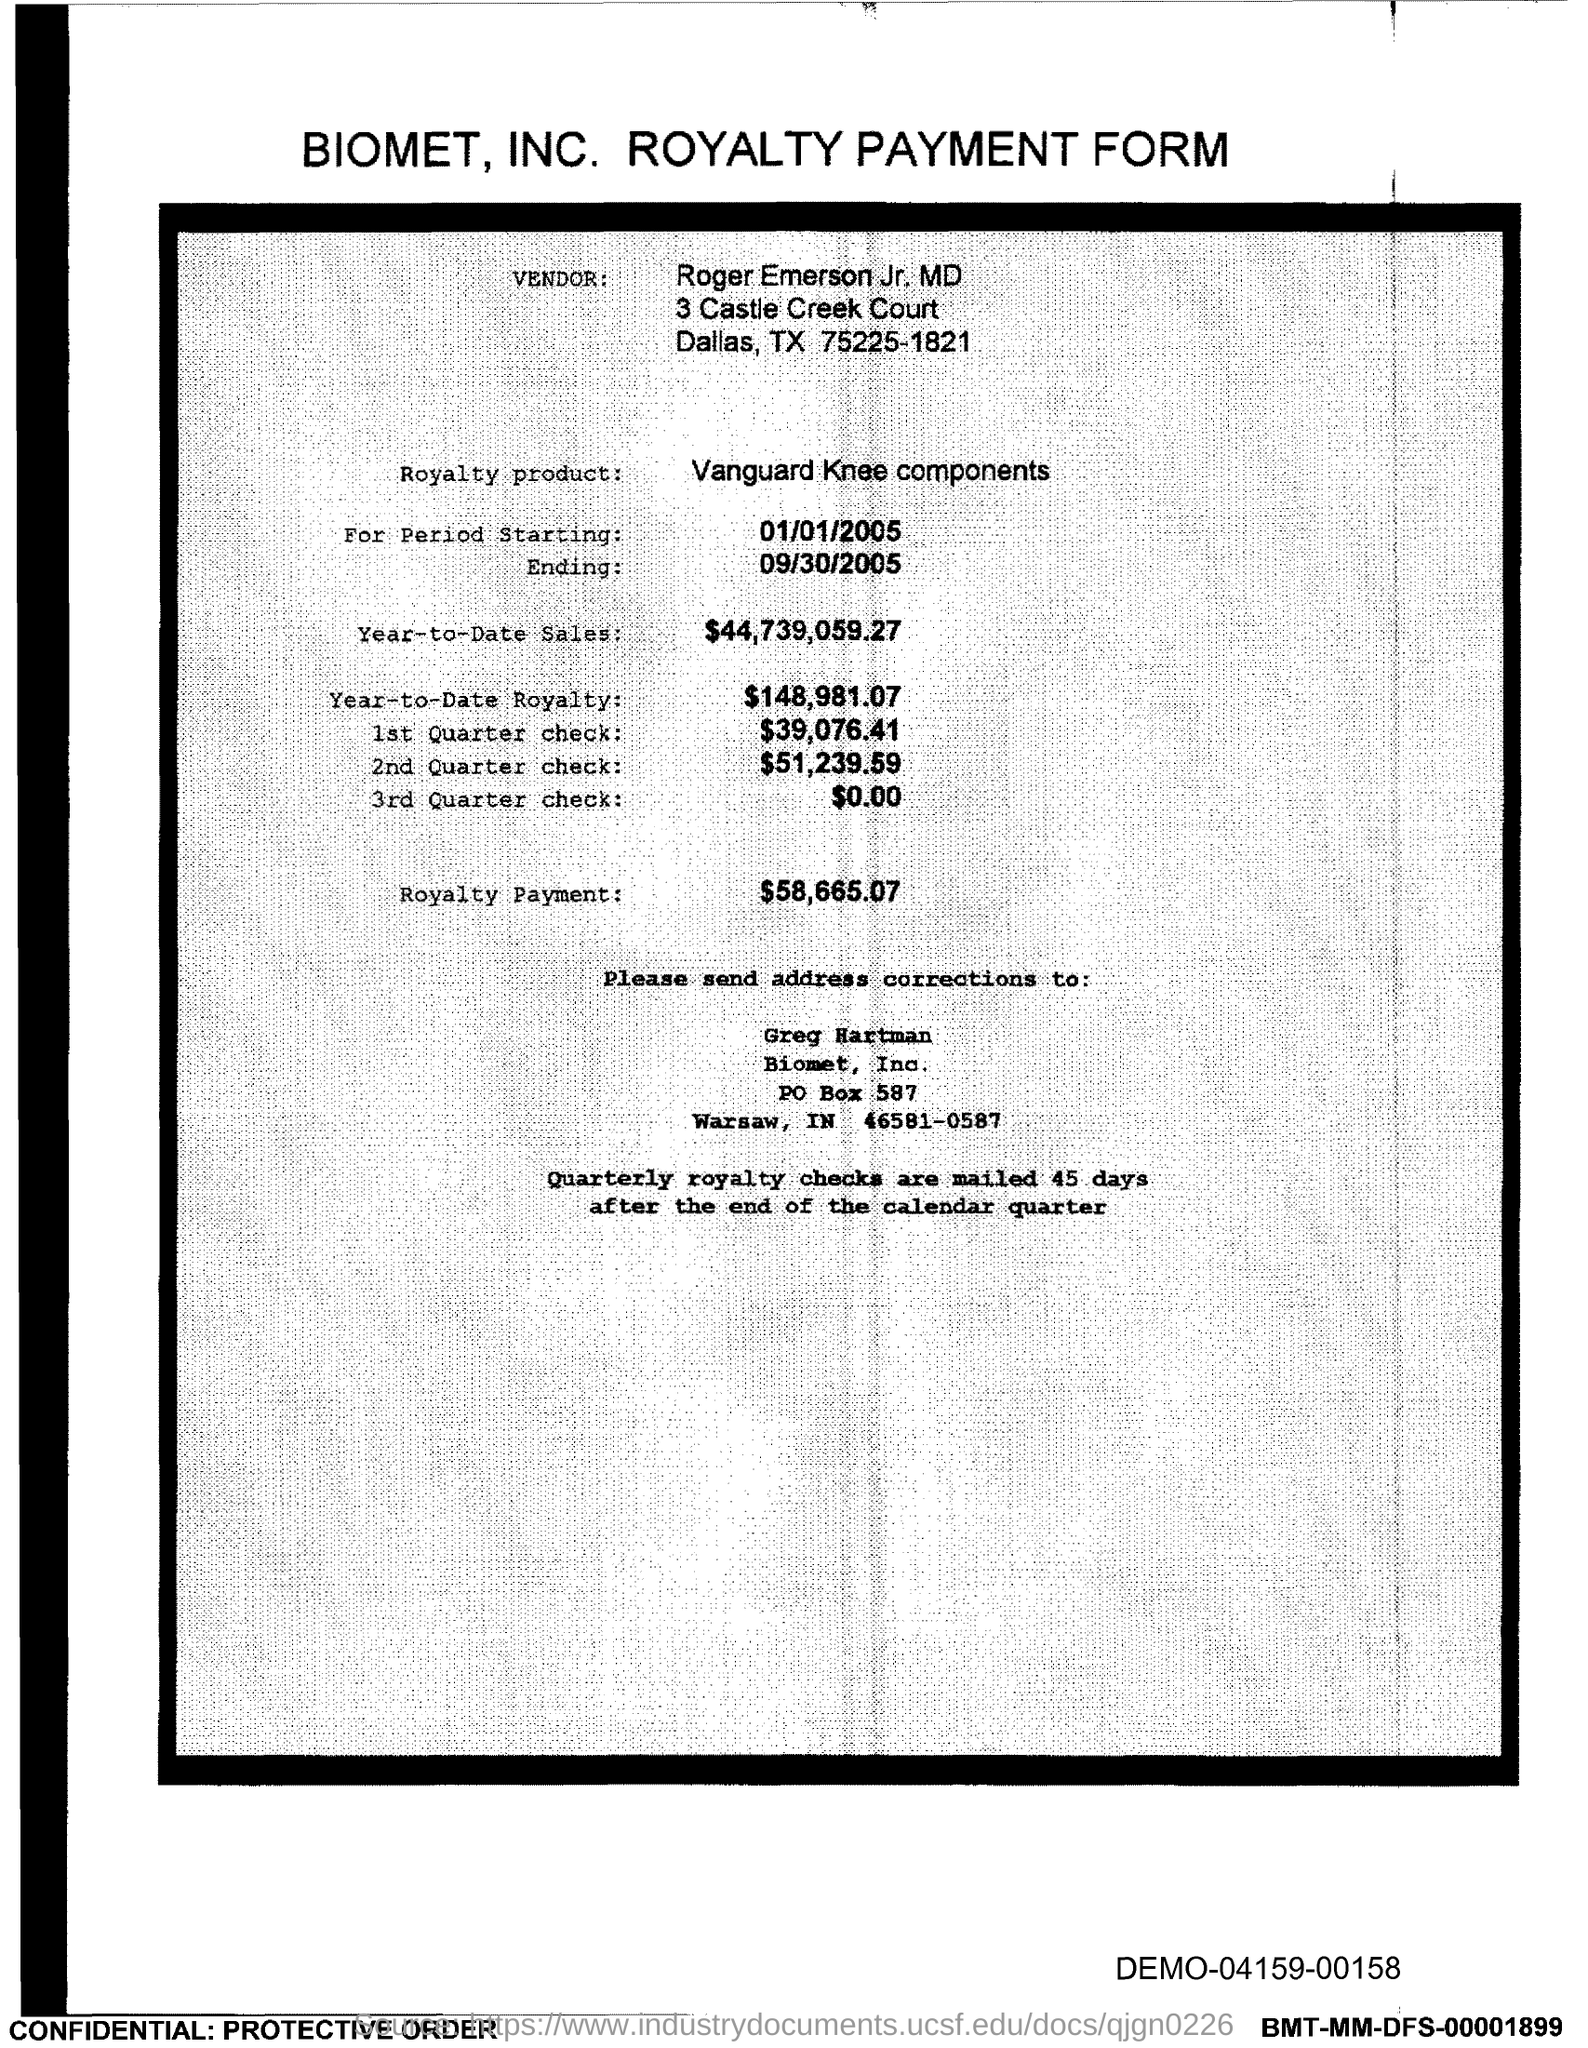What is the PO Box Number mentioned in the document?
Ensure brevity in your answer.  587. 